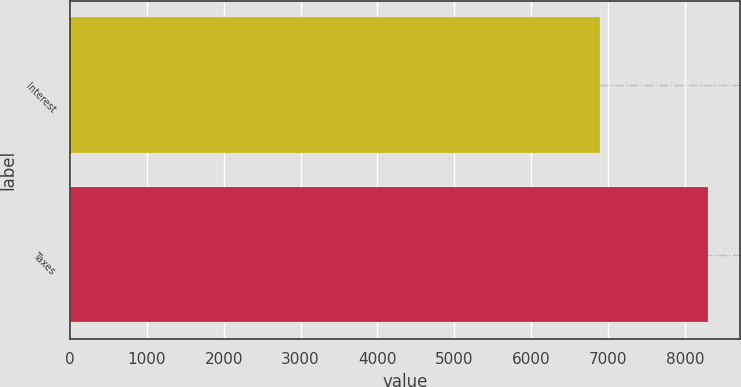Convert chart to OTSL. <chart><loc_0><loc_0><loc_500><loc_500><bar_chart><fcel>Interest<fcel>Taxes<nl><fcel>6902<fcel>8301<nl></chart> 